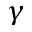Convert formula to latex. <formula><loc_0><loc_0><loc_500><loc_500>\gamma</formula> 